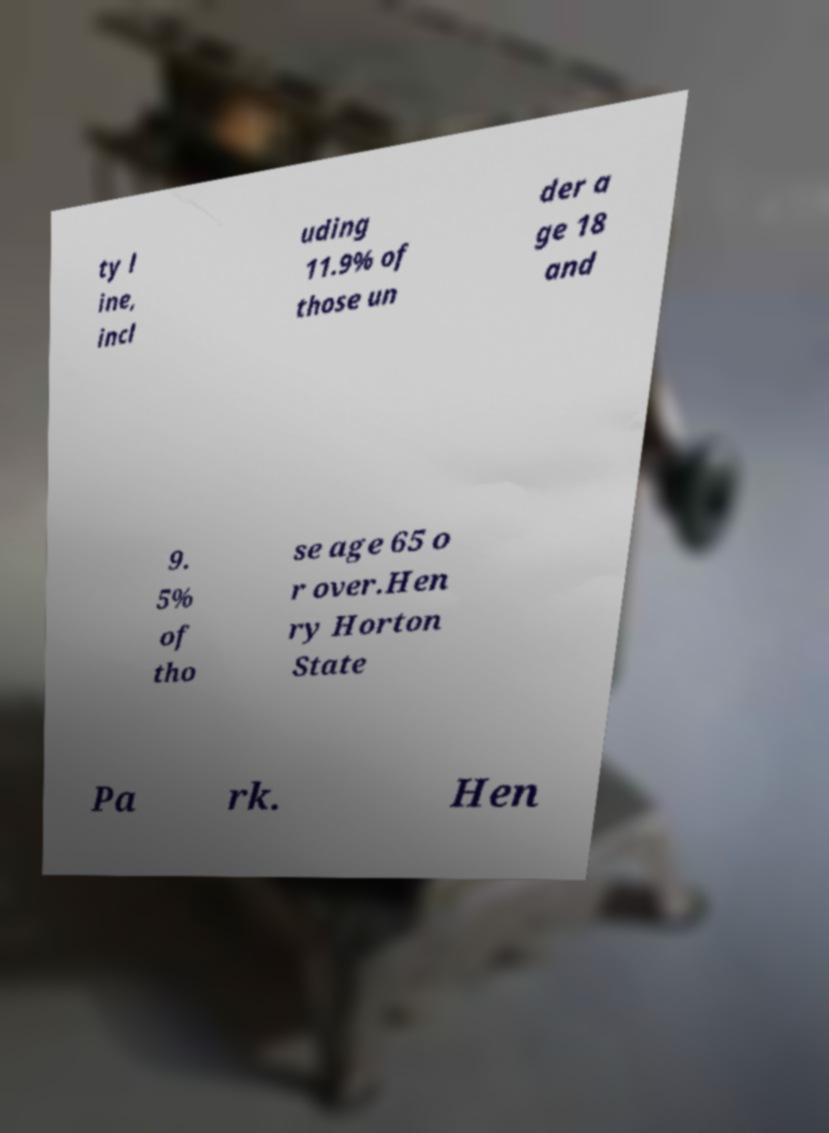Can you accurately transcribe the text from the provided image for me? ty l ine, incl uding 11.9% of those un der a ge 18 and 9. 5% of tho se age 65 o r over.Hen ry Horton State Pa rk. Hen 